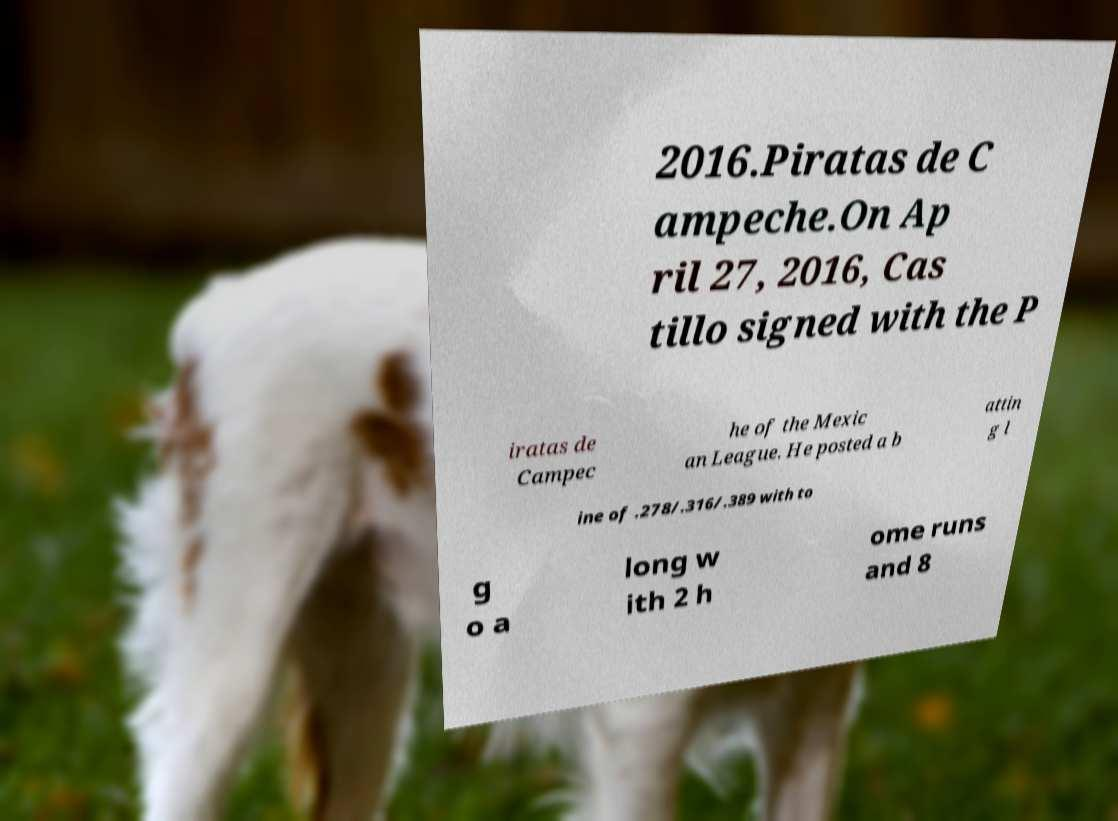I need the written content from this picture converted into text. Can you do that? 2016.Piratas de C ampeche.On Ap ril 27, 2016, Cas tillo signed with the P iratas de Campec he of the Mexic an League. He posted a b attin g l ine of .278/.316/.389 with to g o a long w ith 2 h ome runs and 8 